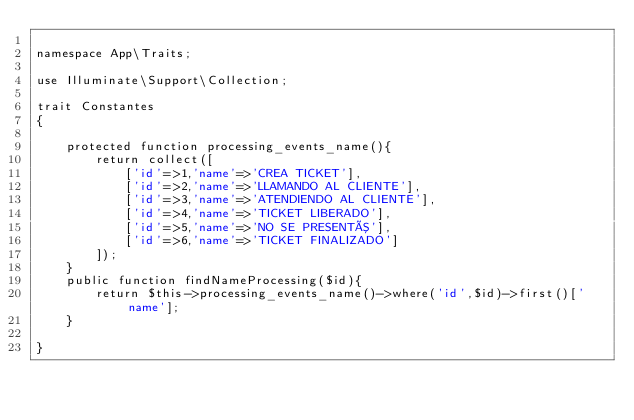<code> <loc_0><loc_0><loc_500><loc_500><_PHP_>
namespace App\Traits;

use Illuminate\Support\Collection;

trait Constantes
{

    protected function processing_events_name(){
        return collect([
            ['id'=>1,'name'=>'CREA TICKET'],
            ['id'=>2,'name'=>'LLAMANDO AL CLIENTE'],
            ['id'=>3,'name'=>'ATENDIENDO AL CLIENTE'],
            ['id'=>4,'name'=>'TICKET LIBERADO'],
            ['id'=>5,'name'=>'NO SE PRESENTÓ'],
            ['id'=>6,'name'=>'TICKET FINALIZADO']
        ]);
    }
    public function findNameProcessing($id){
        return $this->processing_events_name()->where('id',$id)->first()['name'];
    }

}
</code> 